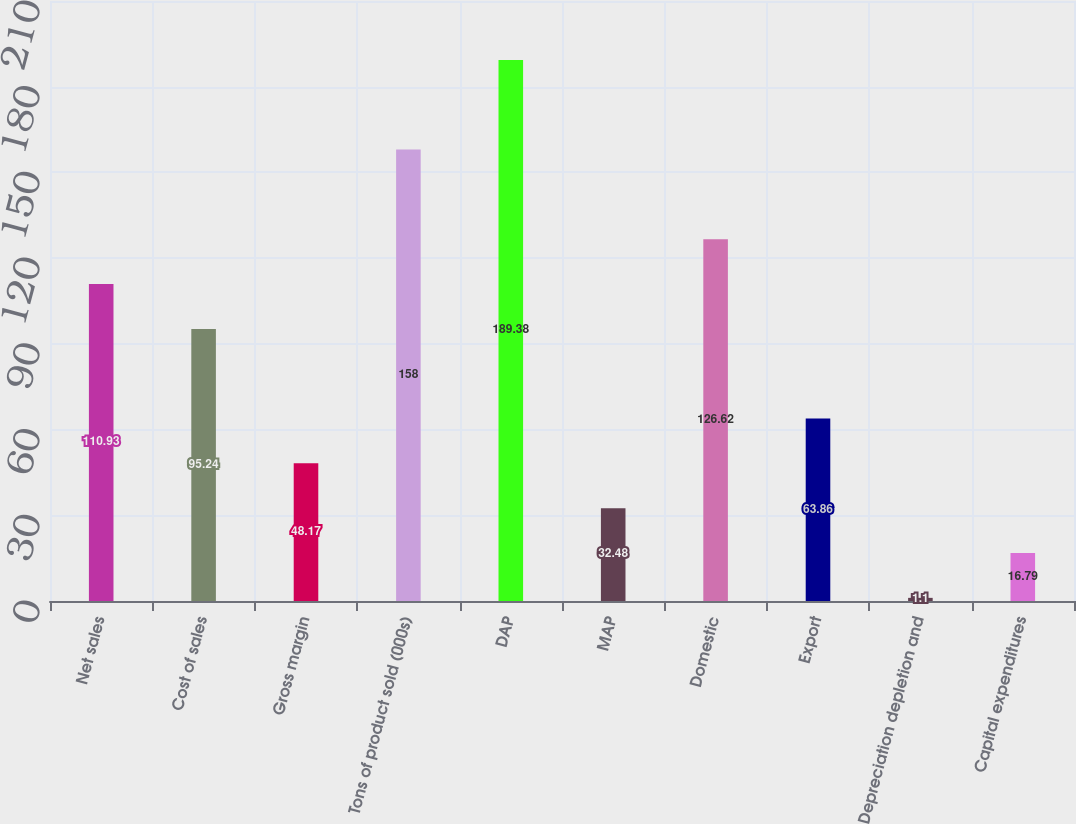<chart> <loc_0><loc_0><loc_500><loc_500><bar_chart><fcel>Net sales<fcel>Cost of sales<fcel>Gross margin<fcel>Tons of product sold (000s)<fcel>DAP<fcel>MAP<fcel>Domestic<fcel>Export<fcel>Depreciation depletion and<fcel>Capital expenditures<nl><fcel>110.93<fcel>95.24<fcel>48.17<fcel>158<fcel>189.38<fcel>32.48<fcel>126.62<fcel>63.86<fcel>1.1<fcel>16.79<nl></chart> 